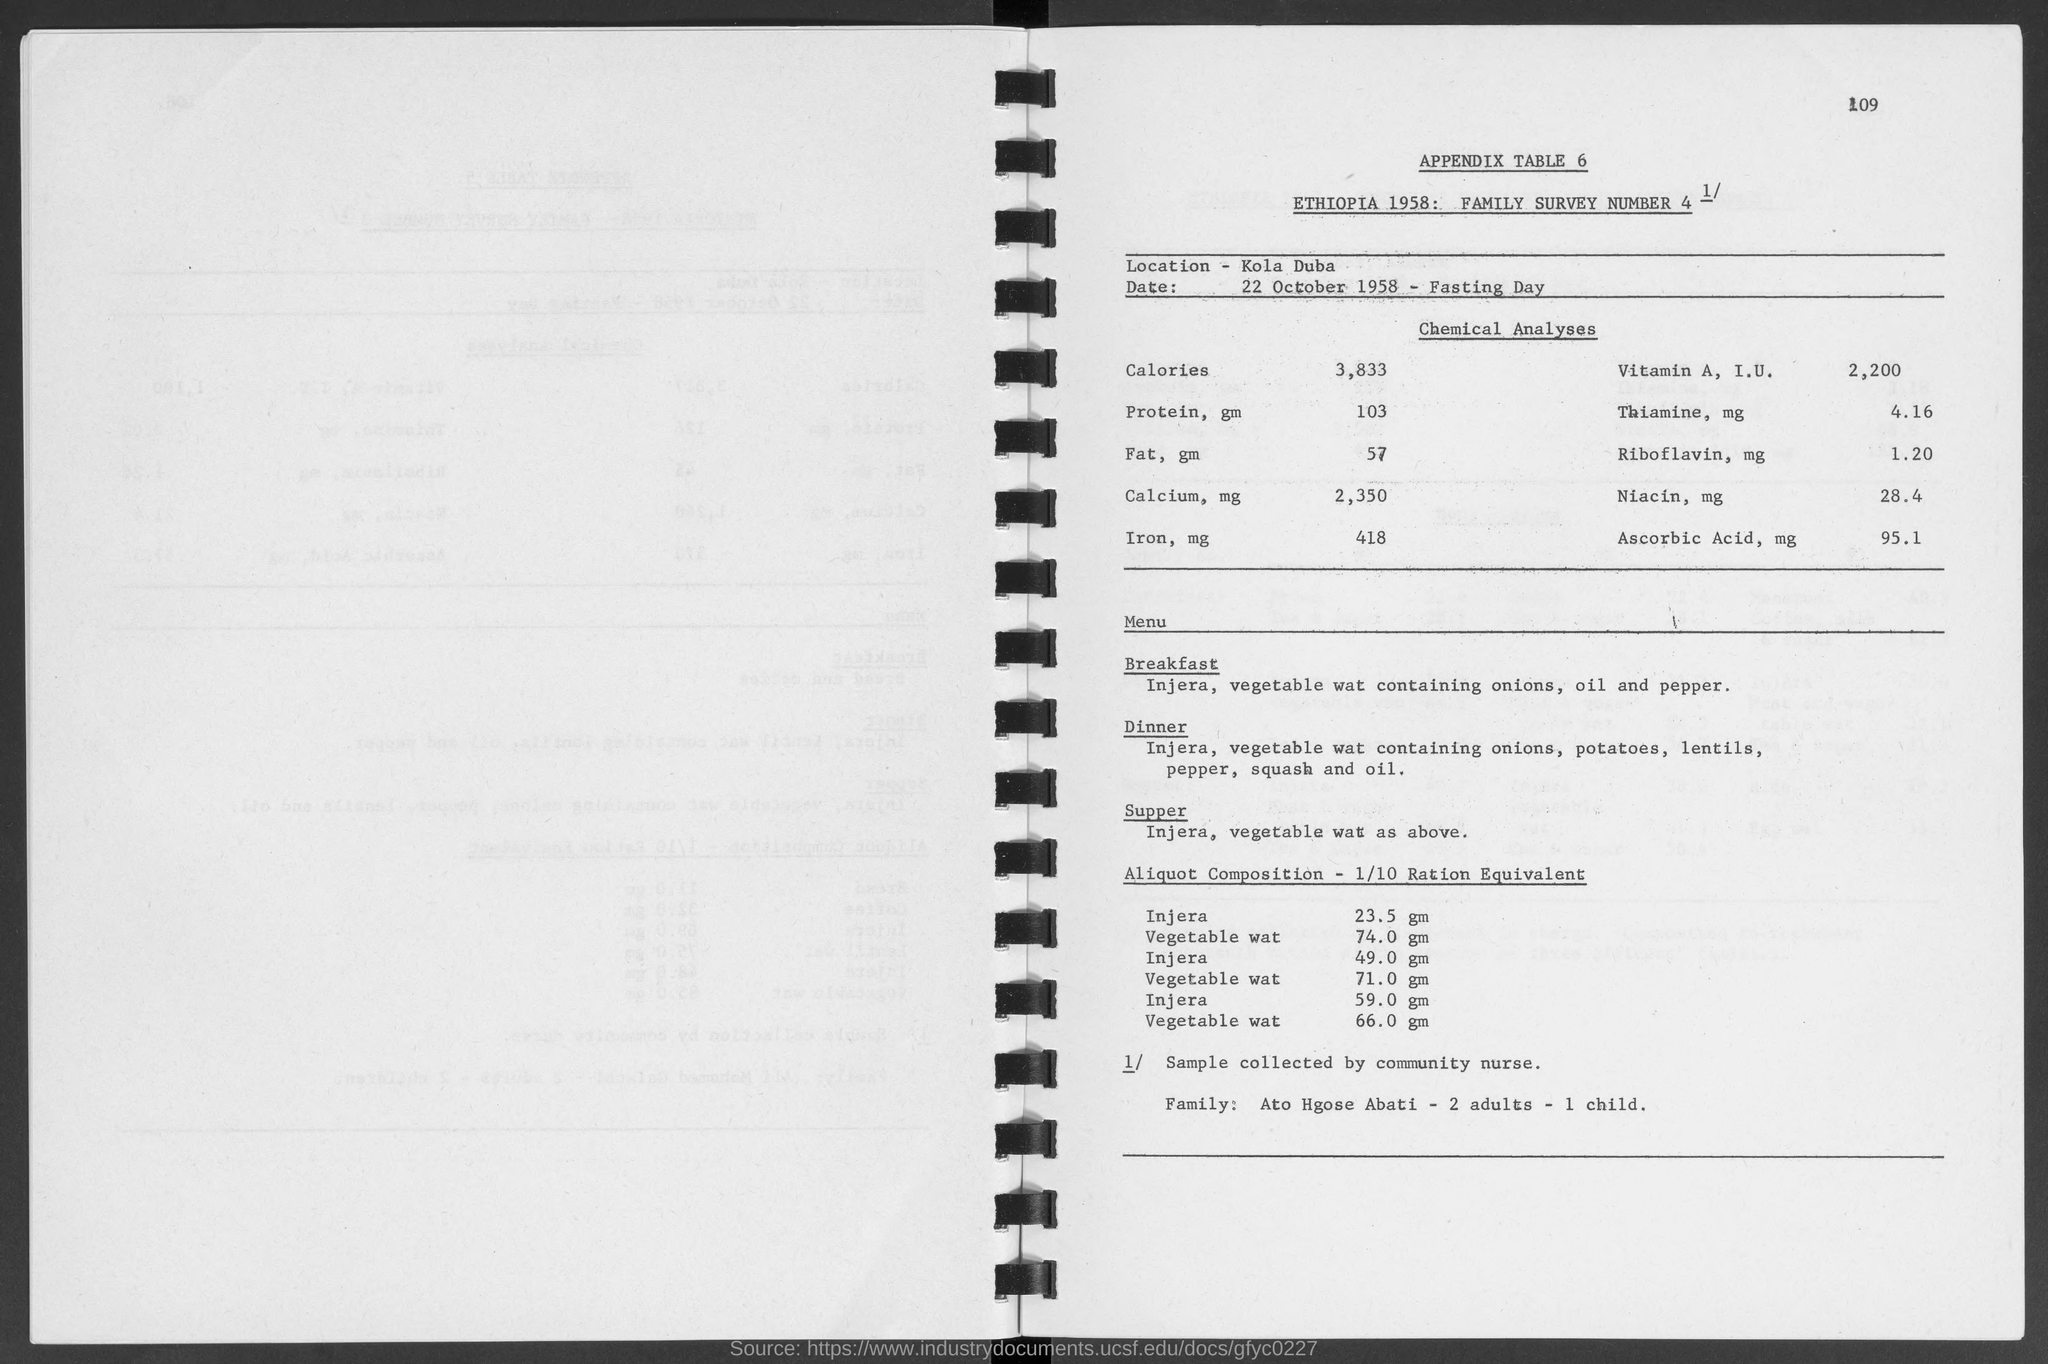Outline some significant characteristics in this image. The sample for this test was collected by a community nurse. KOLA DUBA is located on the table. The common menu item is Injera, which is accompanied by a vegetable wat. 